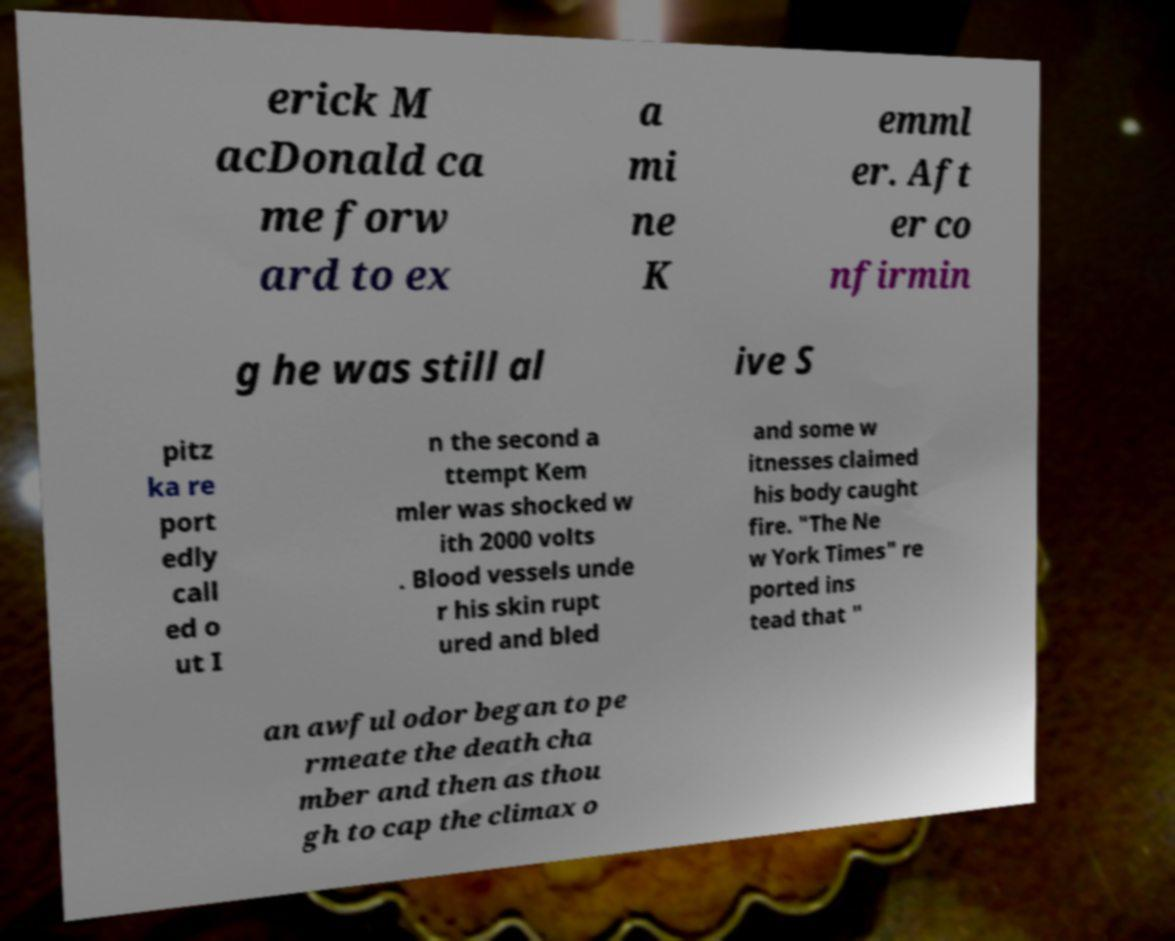For documentation purposes, I need the text within this image transcribed. Could you provide that? erick M acDonald ca me forw ard to ex a mi ne K emml er. Aft er co nfirmin g he was still al ive S pitz ka re port edly call ed o ut I n the second a ttempt Kem mler was shocked w ith 2000 volts . Blood vessels unde r his skin rupt ured and bled and some w itnesses claimed his body caught fire. "The Ne w York Times" re ported ins tead that " an awful odor began to pe rmeate the death cha mber and then as thou gh to cap the climax o 